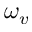Convert formula to latex. <formula><loc_0><loc_0><loc_500><loc_500>\omega _ { v }</formula> 